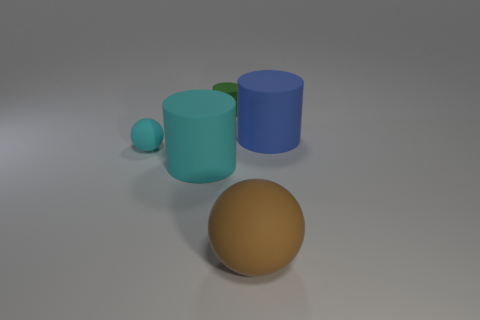What is the green object made of?
Offer a very short reply. Rubber. What shape is the tiny cyan thing that is left of the sphere that is right of the cylinder behind the big blue matte thing?
Ensure brevity in your answer.  Sphere. Is the number of small green rubber things that are in front of the blue cylinder greater than the number of green rubber blocks?
Give a very brief answer. No. Does the big cyan thing have the same shape as the tiny matte object in front of the green rubber cylinder?
Your response must be concise. No. How many matte spheres are on the left side of the cylinder in front of the ball left of the brown object?
Your answer should be very brief. 1. What is the color of the rubber thing that is the same size as the green cylinder?
Your answer should be compact. Cyan. What is the size of the rubber cylinder behind the matte cylinder on the right side of the small green rubber cylinder?
Offer a very short reply. Small. What is the size of the object that is the same color as the small sphere?
Give a very brief answer. Large. How many other things are there of the same size as the green object?
Offer a terse response. 1. What number of large blue objects are there?
Keep it short and to the point. 1. 